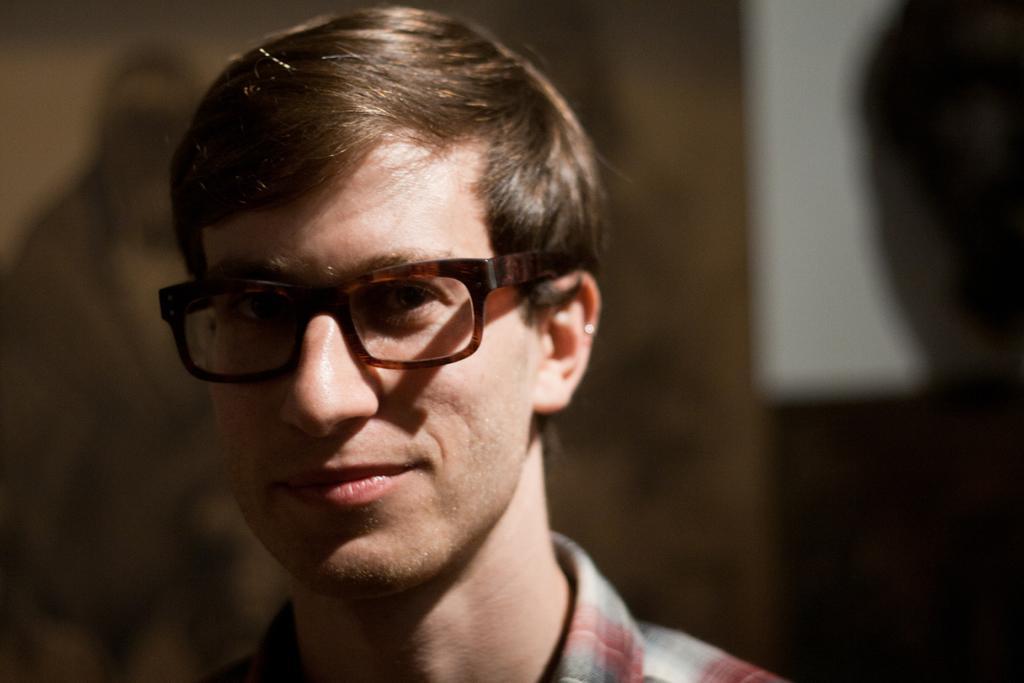Who or what is the main subject of the image? There is a person in the image. What can be observed about the person's appearance? The person is wearing brown-colored spectacles. What colors are present in the background of the image? The background of the image includes brown, black, and white colors. Can you describe the iron waves in the image? There are no iron waves present in the image. 